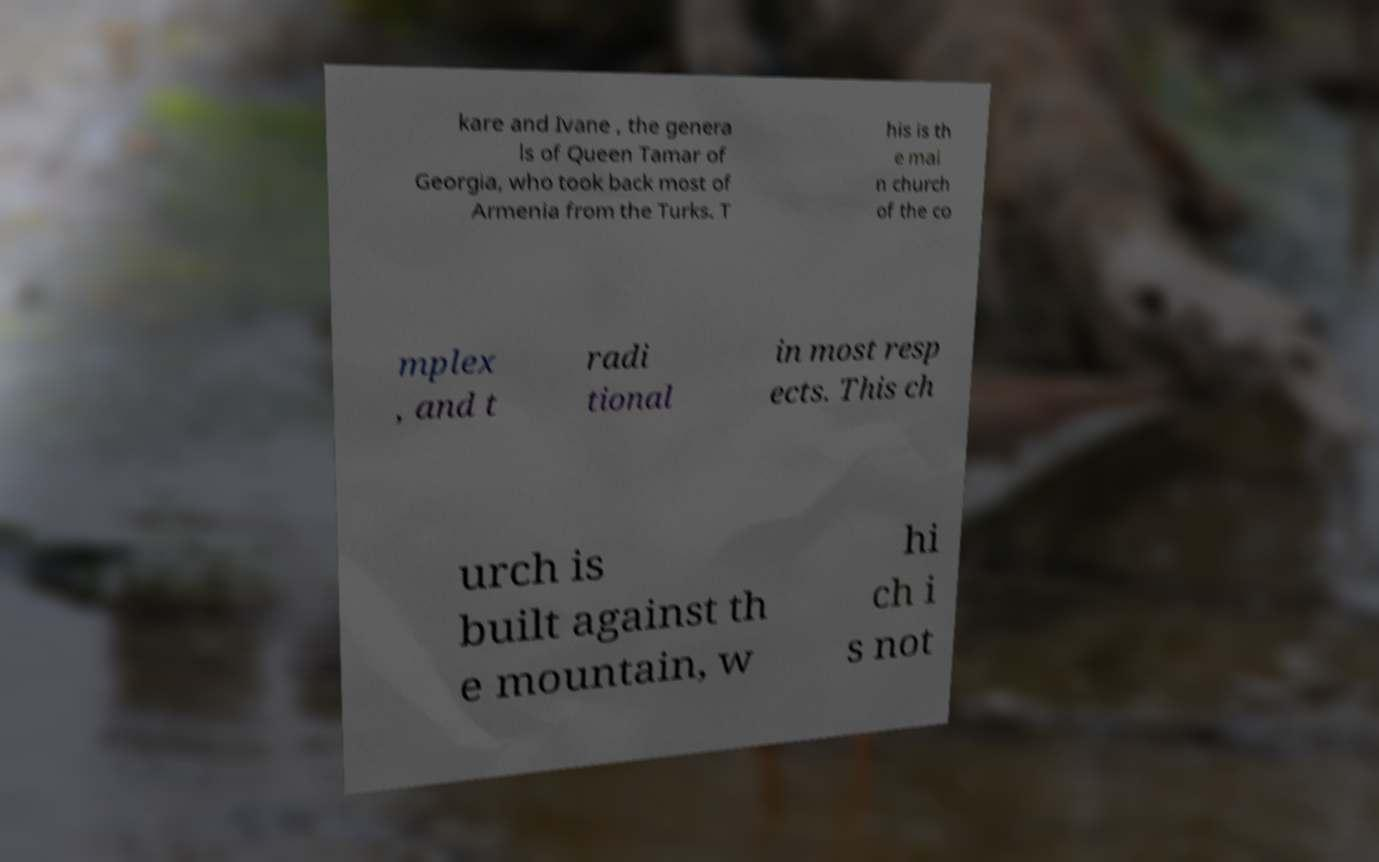What messages or text are displayed in this image? I need them in a readable, typed format. kare and Ivane , the genera ls of Queen Tamar of Georgia, who took back most of Armenia from the Turks. T his is th e mai n church of the co mplex , and t radi tional in most resp ects. This ch urch is built against th e mountain, w hi ch i s not 